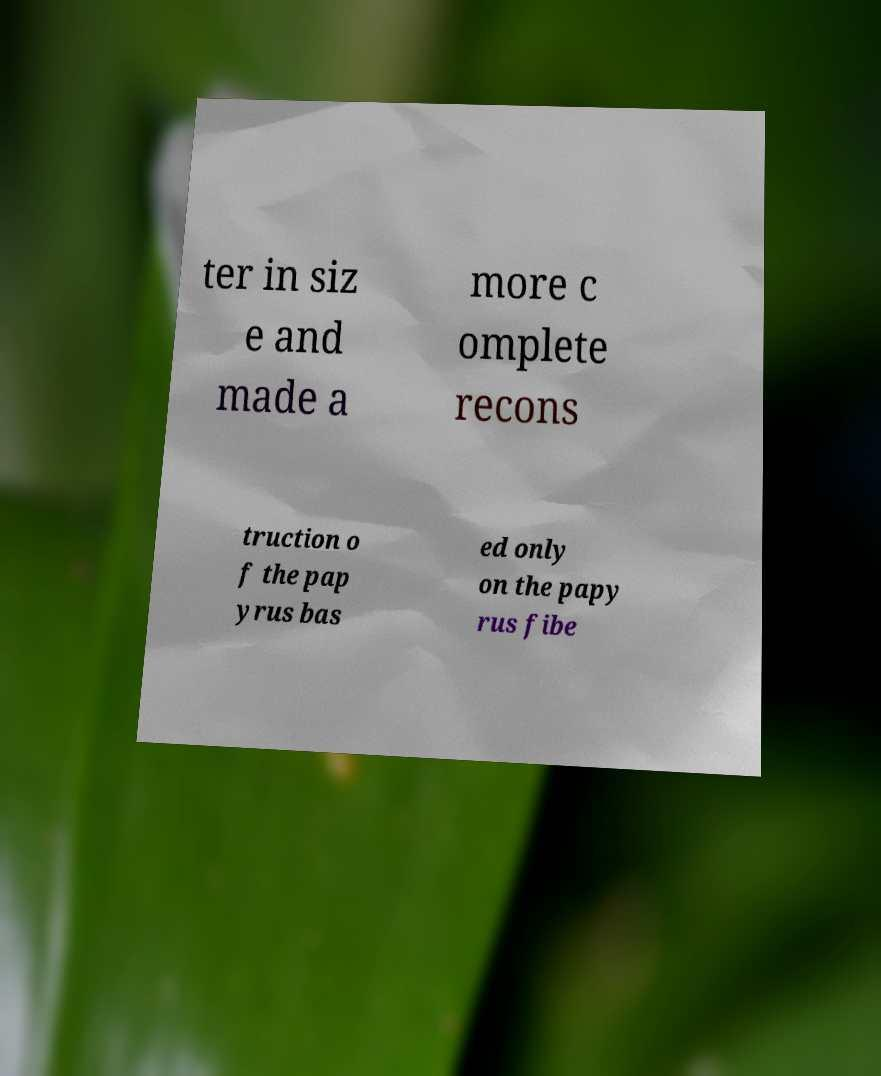There's text embedded in this image that I need extracted. Can you transcribe it verbatim? ter in siz e and made a more c omplete recons truction o f the pap yrus bas ed only on the papy rus fibe 